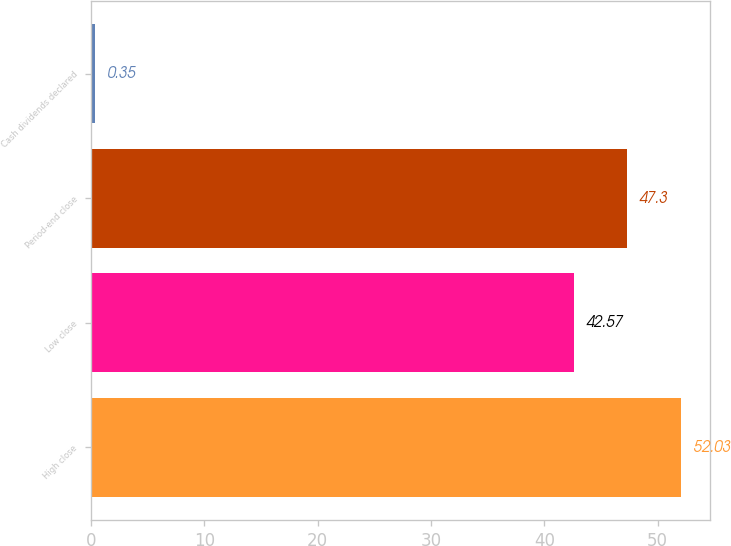<chart> <loc_0><loc_0><loc_500><loc_500><bar_chart><fcel>High close<fcel>Low close<fcel>Period-end close<fcel>Cash dividends declared<nl><fcel>52.03<fcel>42.57<fcel>47.3<fcel>0.35<nl></chart> 